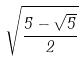Convert formula to latex. <formula><loc_0><loc_0><loc_500><loc_500>\sqrt { \frac { 5 - \sqrt { 5 } } { 2 } }</formula> 